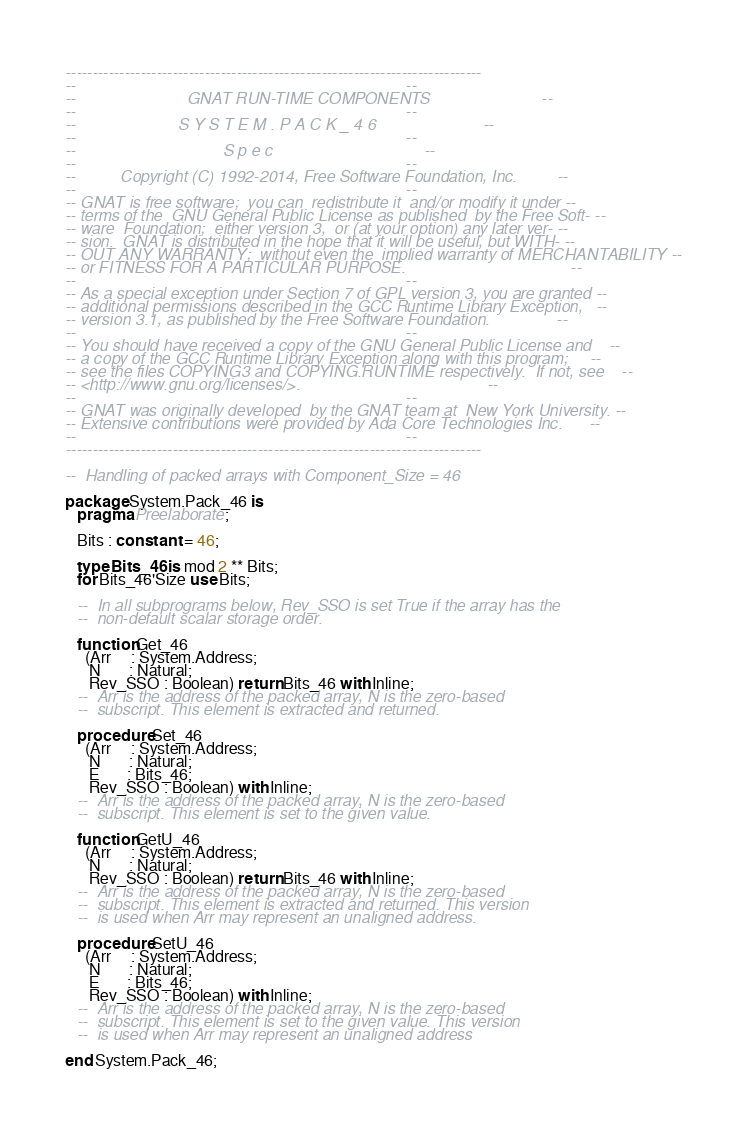Convert code to text. <code><loc_0><loc_0><loc_500><loc_500><_Ada_>------------------------------------------------------------------------------
--                                                                          --
--                         GNAT RUN-TIME COMPONENTS                         --
--                                                                          --
--                       S Y S T E M . P A C K _ 4 6                        --
--                                                                          --
--                                 S p e c                                  --
--                                                                          --
--          Copyright (C) 1992-2014, Free Software Foundation, Inc.         --
--                                                                          --
-- GNAT is free software;  you can  redistribute it  and/or modify it under --
-- terms of the  GNU General Public License as published  by the Free Soft- --
-- ware  Foundation;  either version 3,  or (at your option) any later ver- --
-- sion.  GNAT is distributed in the hope that it will be useful, but WITH- --
-- OUT ANY WARRANTY;  without even the  implied warranty of MERCHANTABILITY --
-- or FITNESS FOR A PARTICULAR PURPOSE.                                     --
--                                                                          --
-- As a special exception under Section 7 of GPL version 3, you are granted --
-- additional permissions described in the GCC Runtime Library Exception,   --
-- version 3.1, as published by the Free Software Foundation.               --
--                                                                          --
-- You should have received a copy of the GNU General Public License and    --
-- a copy of the GCC Runtime Library Exception along with this program;     --
-- see the files COPYING3 and COPYING.RUNTIME respectively.  If not, see    --
-- <http://www.gnu.org/licenses/>.                                          --
--                                                                          --
-- GNAT was originally developed  by the GNAT team at  New York University. --
-- Extensive contributions were provided by Ada Core Technologies Inc.      --
--                                                                          --
------------------------------------------------------------------------------

--  Handling of packed arrays with Component_Size = 46

package System.Pack_46 is
   pragma Preelaborate;

   Bits : constant := 46;

   type Bits_46 is mod 2 ** Bits;
   for Bits_46'Size use Bits;

   --  In all subprograms below, Rev_SSO is set True if the array has the
   --  non-default scalar storage order.

   function Get_46
     (Arr     : System.Address;
      N       : Natural;
      Rev_SSO : Boolean) return Bits_46 with Inline;
   --  Arr is the address of the packed array, N is the zero-based
   --  subscript. This element is extracted and returned.

   procedure Set_46
     (Arr     : System.Address;
      N       : Natural;
      E       : Bits_46;
      Rev_SSO : Boolean) with Inline;
   --  Arr is the address of the packed array, N is the zero-based
   --  subscript. This element is set to the given value.

   function GetU_46
     (Arr     : System.Address;
      N       : Natural;
      Rev_SSO : Boolean) return Bits_46 with Inline;
   --  Arr is the address of the packed array, N is the zero-based
   --  subscript. This element is extracted and returned. This version
   --  is used when Arr may represent an unaligned address.

   procedure SetU_46
     (Arr     : System.Address;
      N       : Natural;
      E       : Bits_46;
      Rev_SSO : Boolean) with Inline;
   --  Arr is the address of the packed array, N is the zero-based
   --  subscript. This element is set to the given value. This version
   --  is used when Arr may represent an unaligned address

end System.Pack_46;
</code> 